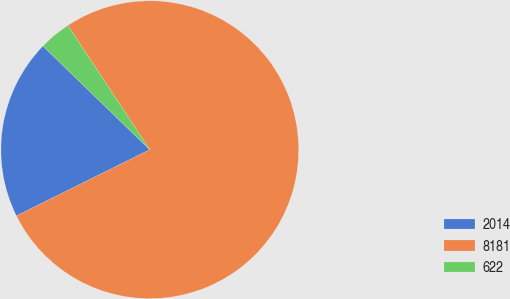Convert chart. <chart><loc_0><loc_0><loc_500><loc_500><pie_chart><fcel>2014<fcel>8181<fcel>622<nl><fcel>19.59%<fcel>76.94%<fcel>3.46%<nl></chart> 